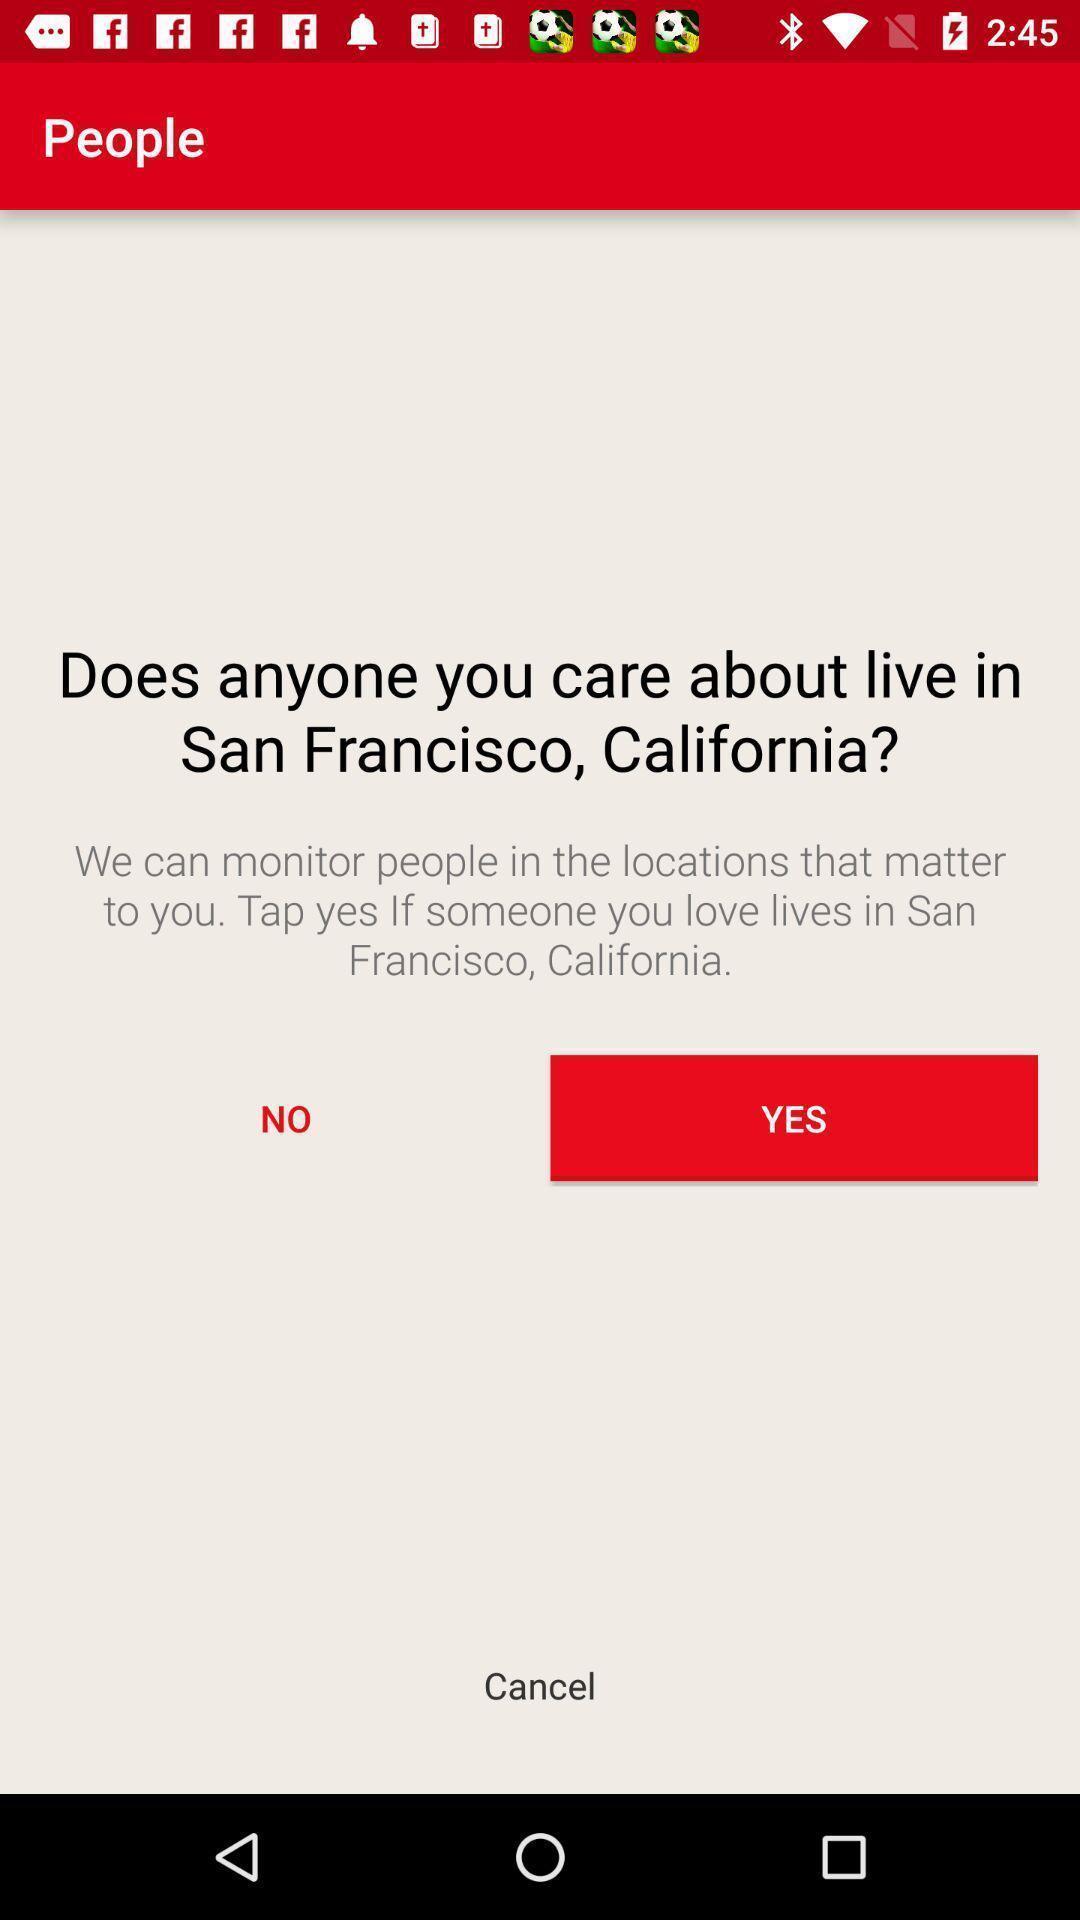Describe this image in words. Page showing options to know who live in san francisco. 